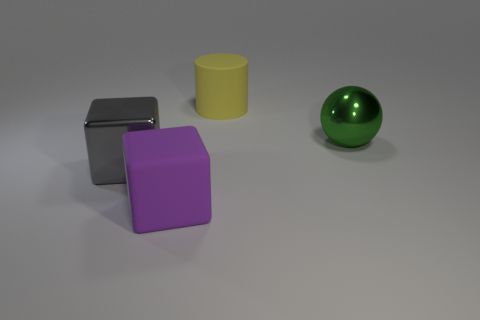Add 1 big green metal spheres. How many objects exist? 5 Subtract all balls. How many objects are left? 3 Subtract 0 purple cylinders. How many objects are left? 4 Subtract all gray metal things. Subtract all tiny green matte things. How many objects are left? 3 Add 4 green shiny objects. How many green shiny objects are left? 5 Add 2 purple rubber cylinders. How many purple rubber cylinders exist? 2 